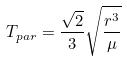Convert formula to latex. <formula><loc_0><loc_0><loc_500><loc_500>T _ { p a r } = \frac { \sqrt { 2 } } { 3 } \sqrt { \frac { r ^ { 3 } } { \mu } }</formula> 